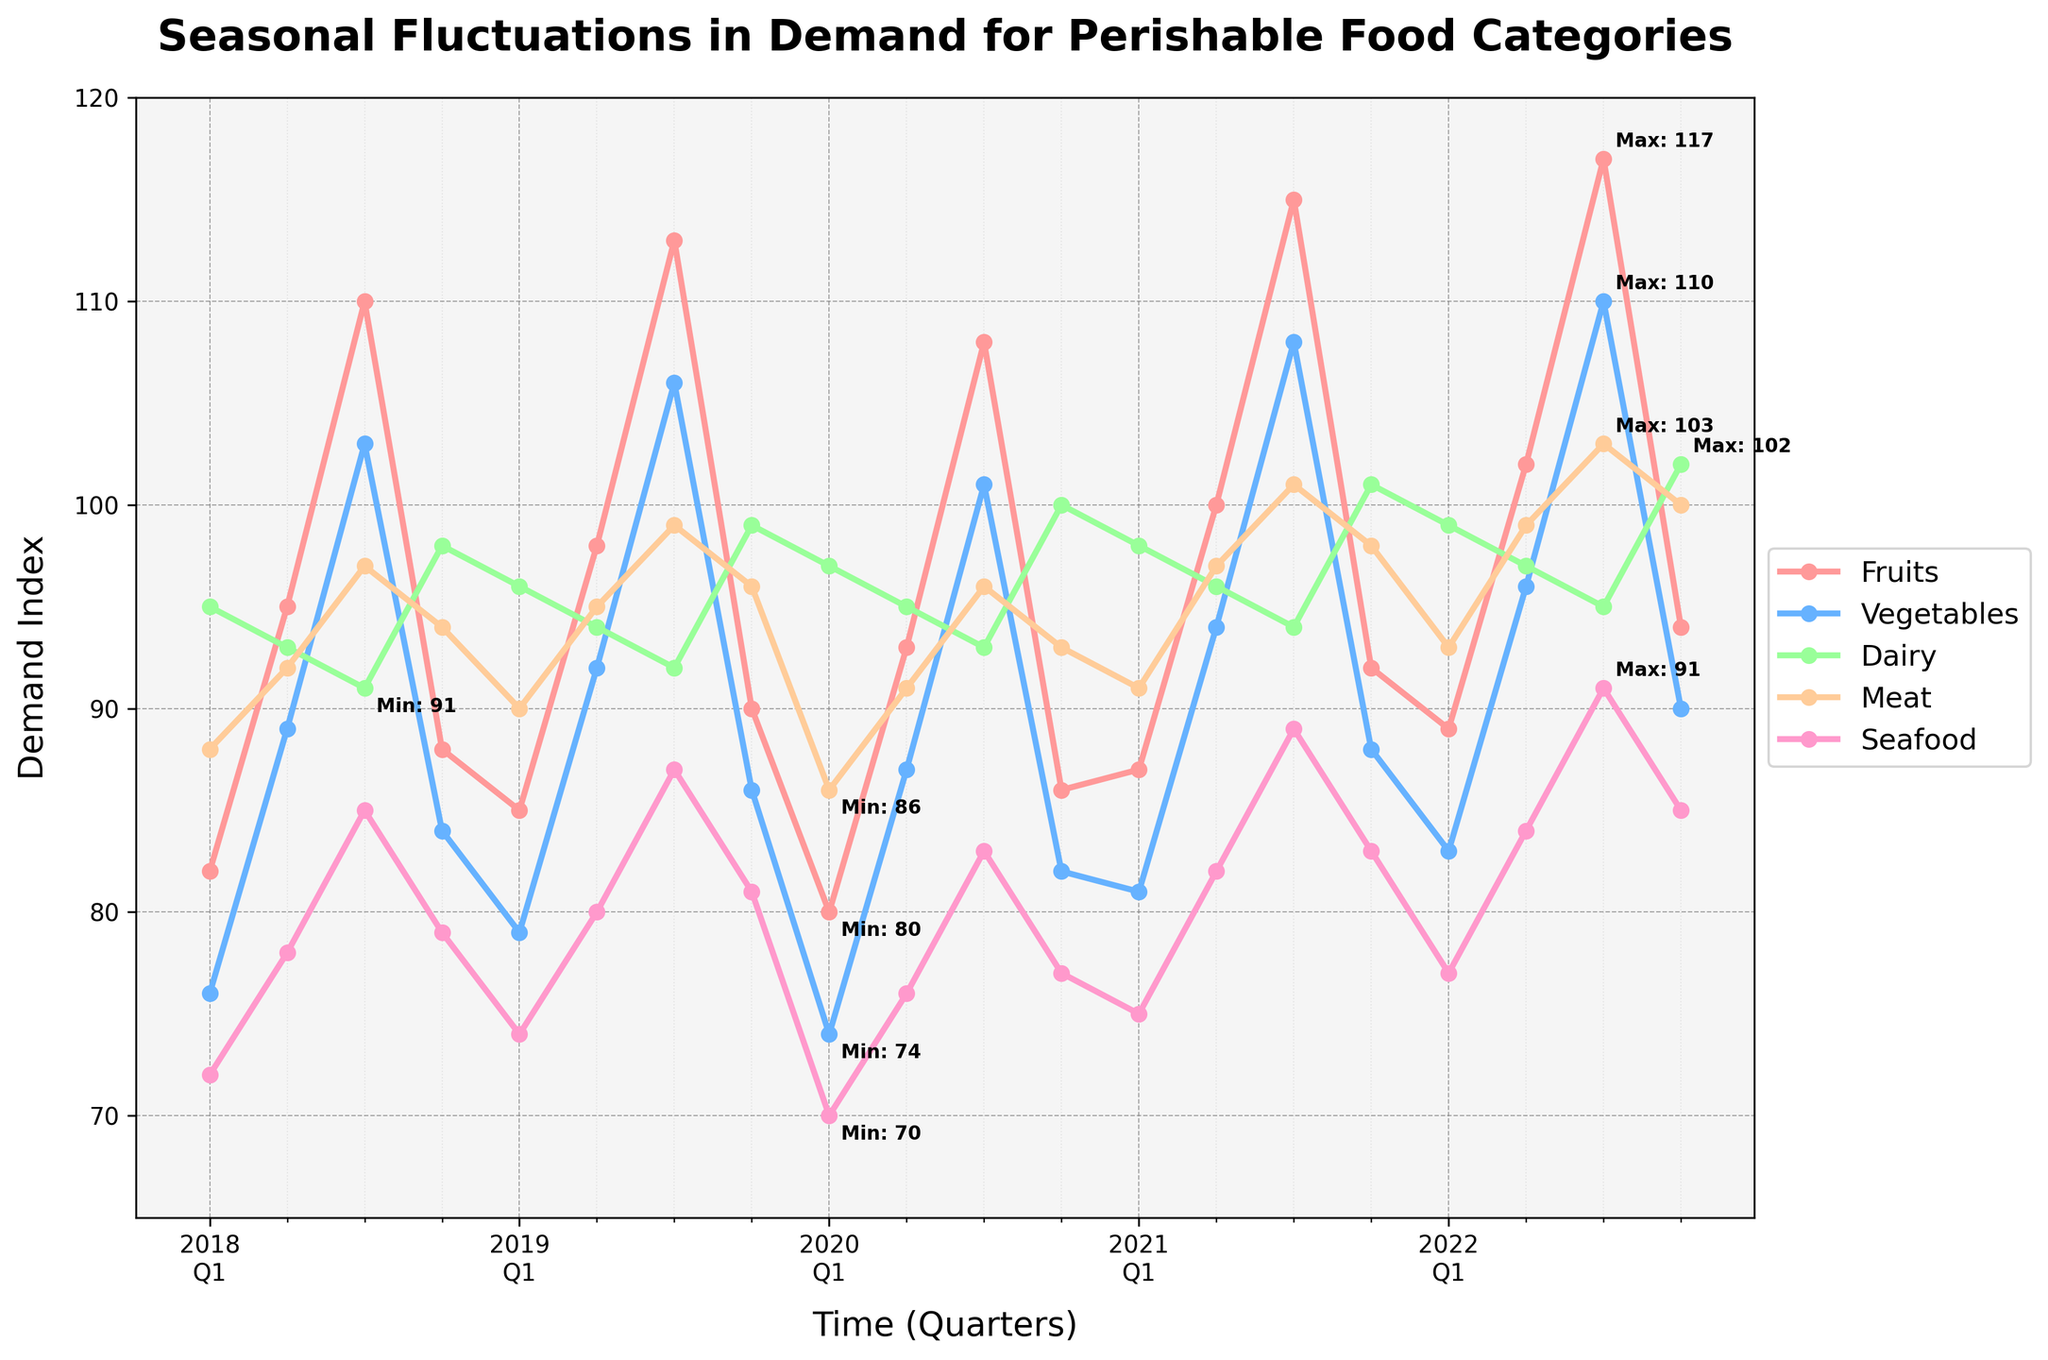What are the maximum and minimum demand indices for fruits over the 5-year period? The chart is annotated with the maximum and minimum values for each category. For fruits, identify the highest and lowest values from the annotations.
Answer: Max: 117, Min: 80 Which food category has the highest demand in Q3 on average across the 5-year period? Combine the demand values for each category in Q3 of all years and compute the averages. The category with the highest average value is the answer. For fruits: (110+113+108+115+117)/5 = 112.6; Vegetables: (103+106+101+108+110)/5 = 105.6; Dairy: (91+92+93+94+95)/5 = 93; Meat: (97+99+96+101+103)/5 = 99.2; Seafood: (85+87+83+89+91)/5 = 87.
Answer: Fruits In which year and quarter did dairy reach its highest demand? The chart is annotated with the maximum value for dairy. Identify the corresponding year and quarter from the data.
Answer: 2022 Q4 During which quarter do vegetables show a consistent incremental increase in demand? Observe the quarters where vegetable demand increases consistently over consecutive years. Check for a steady rise from one quarter to the next within the same quarters across different years. The increase should be incremental and consistent without drops.
Answer: Q3 Which category experiences the most fluctuation in demand over the 5-year period? To determine the category with the most fluctuation, calculate the range for each category (max value - min value) from the annotations and data. The category with the largest range has the most fluctuation. For example, fruits: 117-80=37; vegetables: 110-74=36; dairy: 102-91=11; meat: 103-86=17; seafood: 91-70=21.
Answer: Fruits 